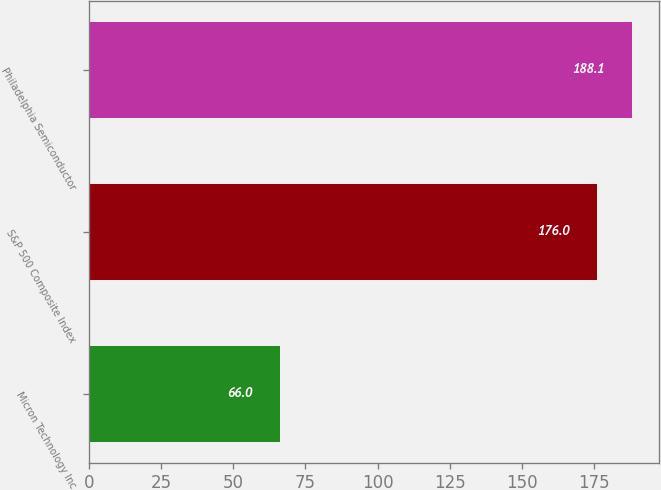Convert chart. <chart><loc_0><loc_0><loc_500><loc_500><bar_chart><fcel>Micron Technology Inc<fcel>S&P 500 Composite Index<fcel>Philadelphia Semiconductor<nl><fcel>66<fcel>176<fcel>188.1<nl></chart> 